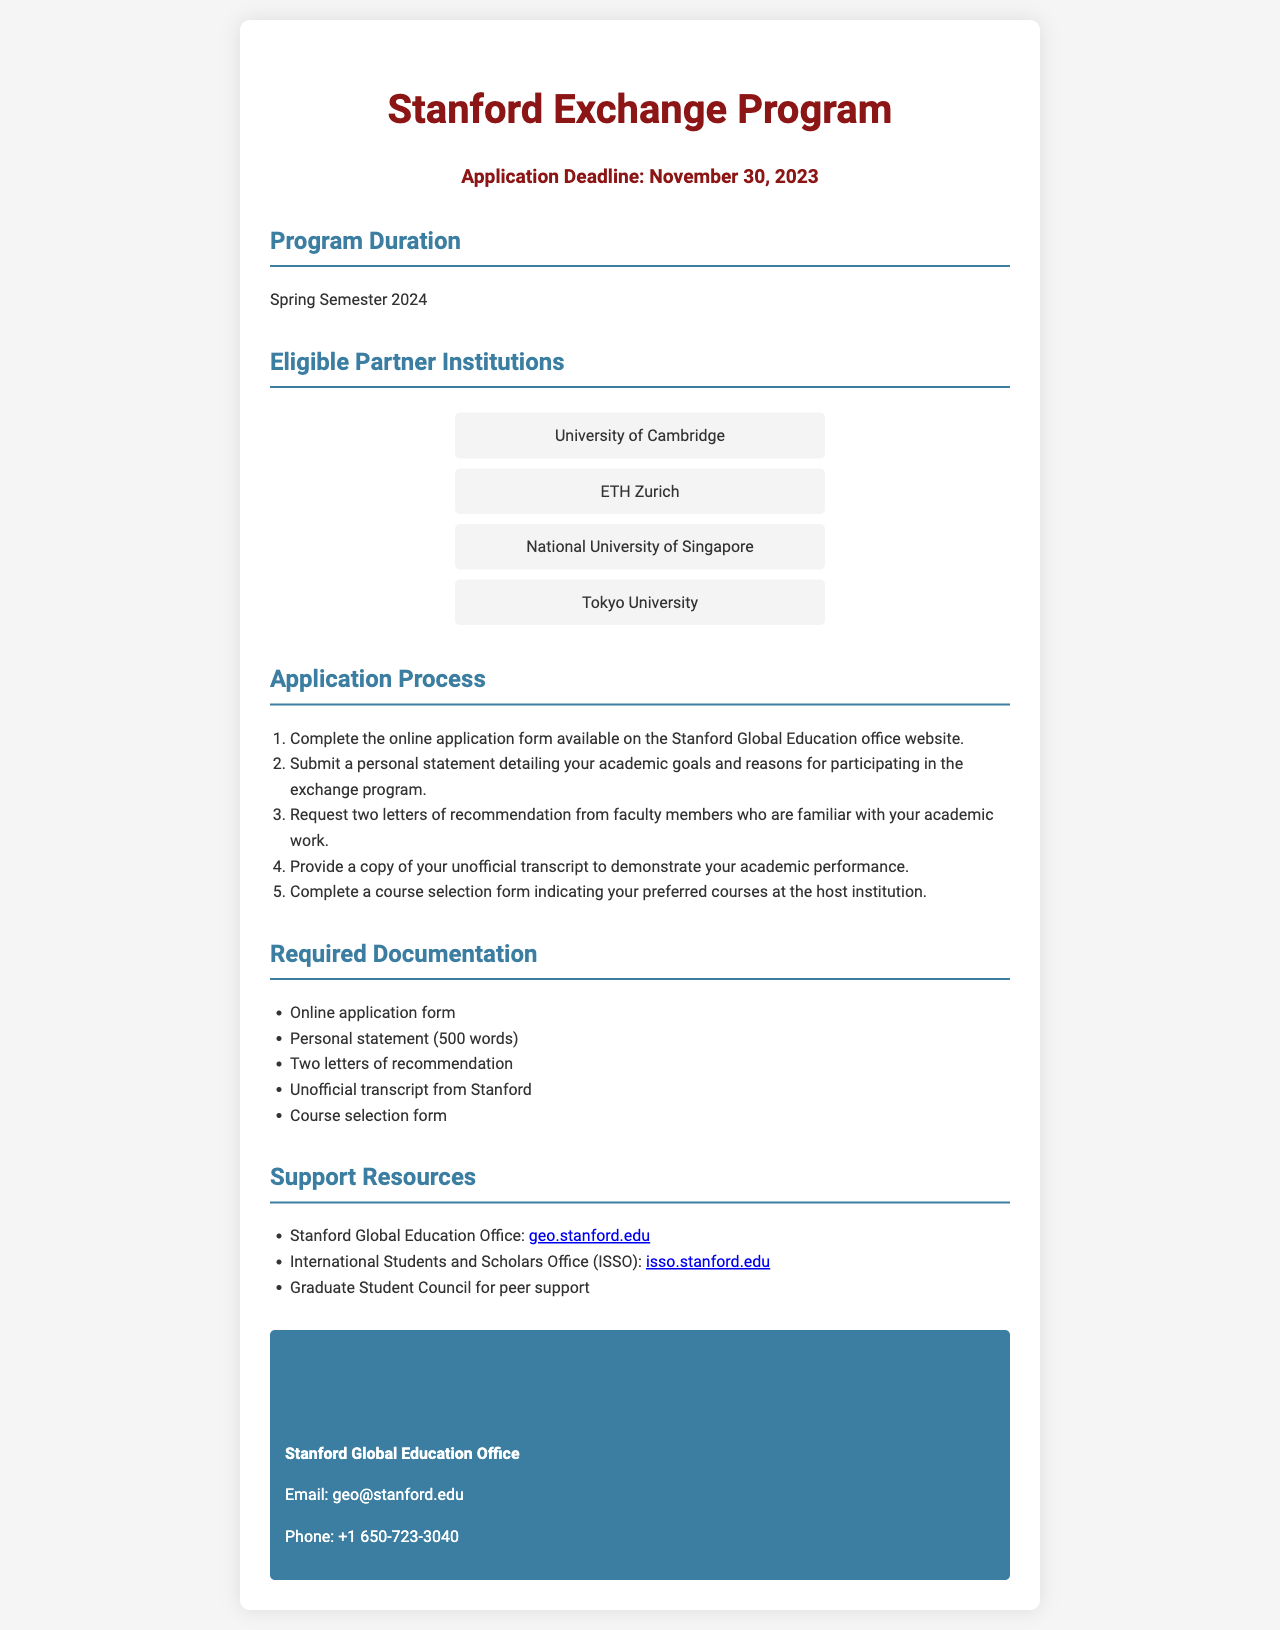What is the application deadline? The application deadline is explicitly stated in the document.
Answer: November 30, 2023 What semester is the program for? The document mentions the specific semester for which the program is being held.
Answer: Spring Semester 2024 How many letters of recommendation are required? The document specifies that a certain number of letters must be submitted for the application.
Answer: Two What is the maximum word count for the personal statement? The document indicates the length requirement for the personal statement.
Answer: 500 words Which institution is NOT listed as an eligible partner? The question asks for an institution that is not mentioned among the eligible partners in the document.
Answer: (Any institution not listed) What office must the online application be submitted to? The document specifies the office responsible for handling applications.
Answer: Stanford Global Education Office What type of transcript is required? The document specifies which type of transcript should be provided by the applicants.
Answer: Unofficial transcript What is the contact email provided in the document? The document includes the email address for getting in touch with the relevant office.
Answer: geo@stanford.edu 